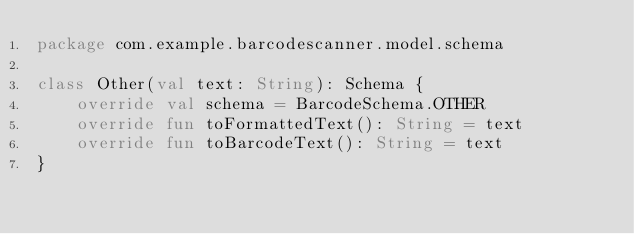<code> <loc_0><loc_0><loc_500><loc_500><_Kotlin_>package com.example.barcodescanner.model.schema

class Other(val text: String): Schema {
    override val schema = BarcodeSchema.OTHER
    override fun toFormattedText(): String = text
    override fun toBarcodeText(): String = text
}</code> 